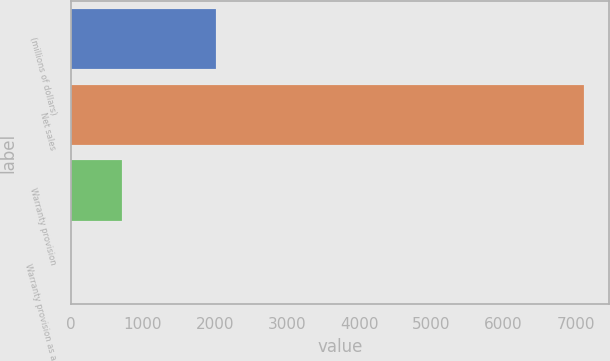<chart> <loc_0><loc_0><loc_500><loc_500><bar_chart><fcel>(millions of dollars)<fcel>Net sales<fcel>Warranty provision<fcel>Warranty provision as a<nl><fcel>2011<fcel>7114.7<fcel>712.1<fcel>0.7<nl></chart> 